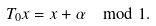Convert formula to latex. <formula><loc_0><loc_0><loc_500><loc_500>T _ { 0 } x = x + \alpha \mod 1 .</formula> 